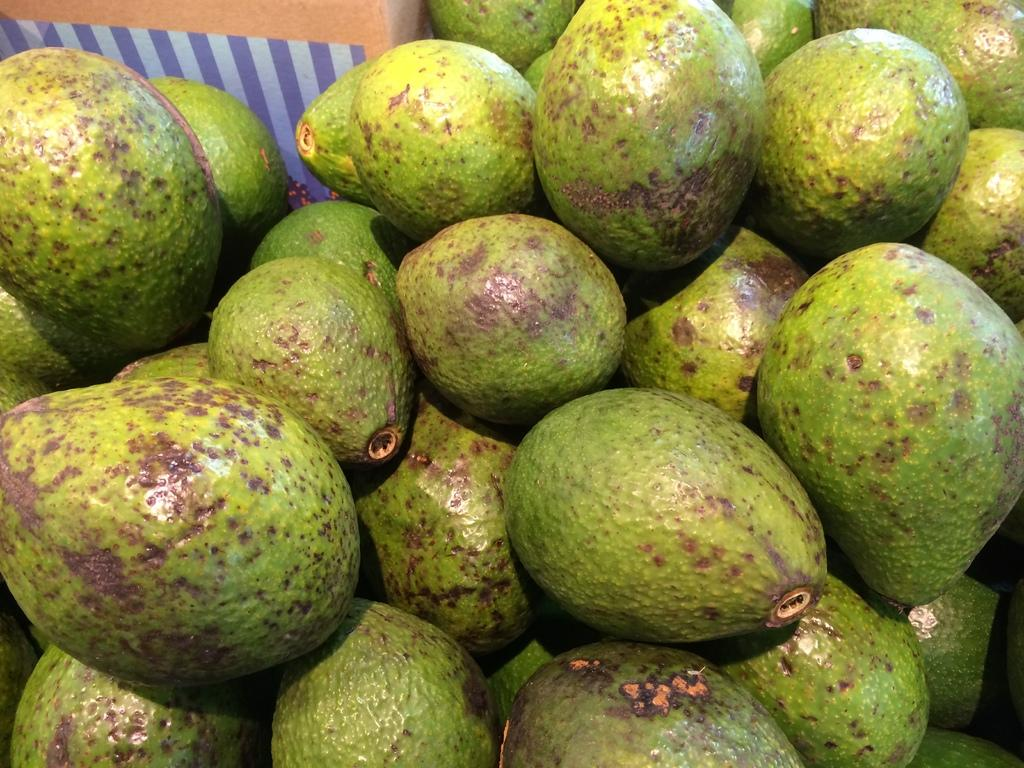What type of food can be seen in the image? There are fruits in the image. What color are the fruits in the image? The fruits are green in color. What type of books can be seen in the image? There are no books present in the image; it features green fruits. 